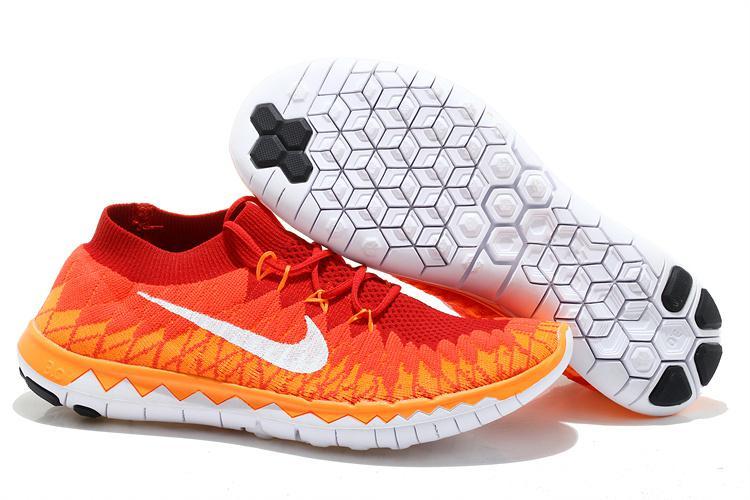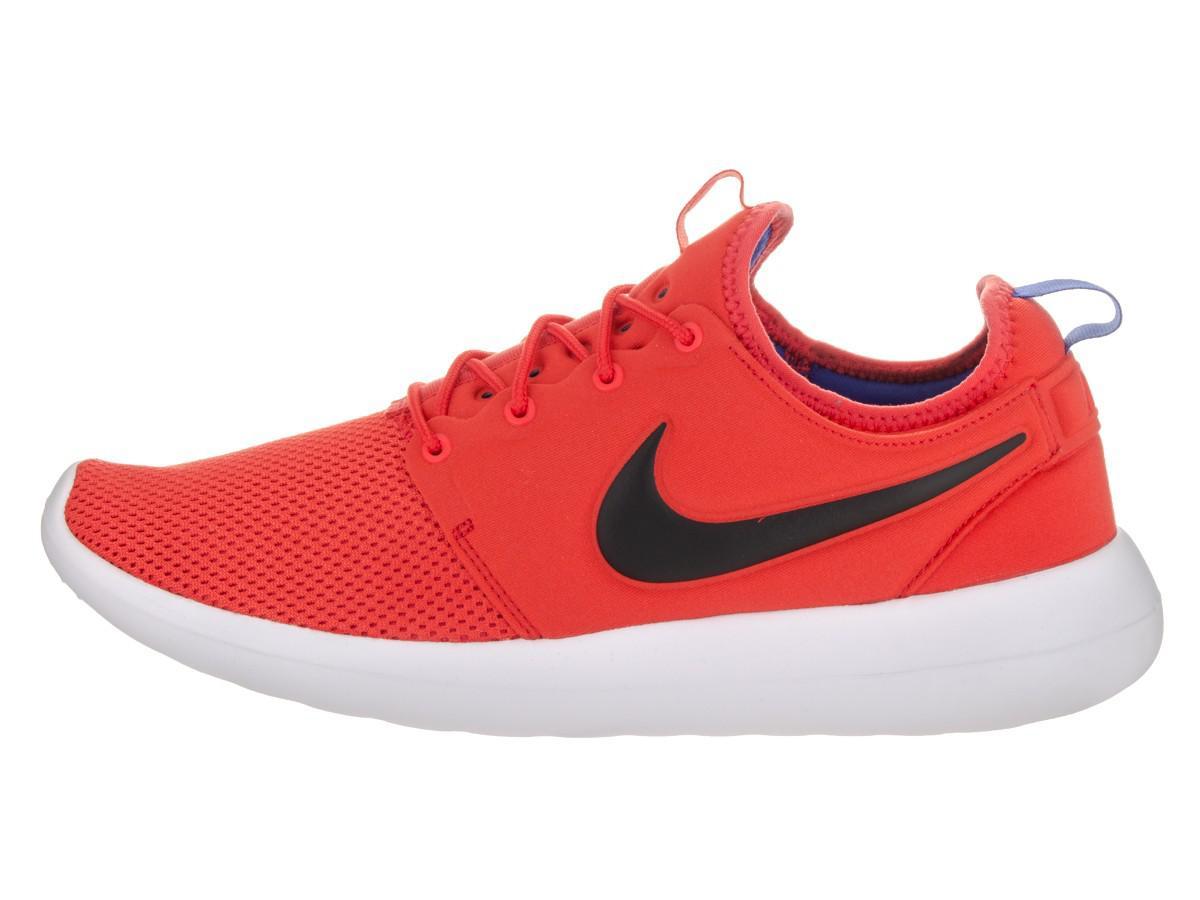The first image is the image on the left, the second image is the image on the right. Considering the images on both sides, is "The right image contains no more than one shoe." valid? Answer yes or no. Yes. The first image is the image on the left, the second image is the image on the right. Given the left and right images, does the statement "One image shows a pair of sneakers, with one shoe posed with the sole facing the camera and the other shoe pointed rightward, and the other image shows a single sneaker turned leftward." hold true? Answer yes or no. Yes. 